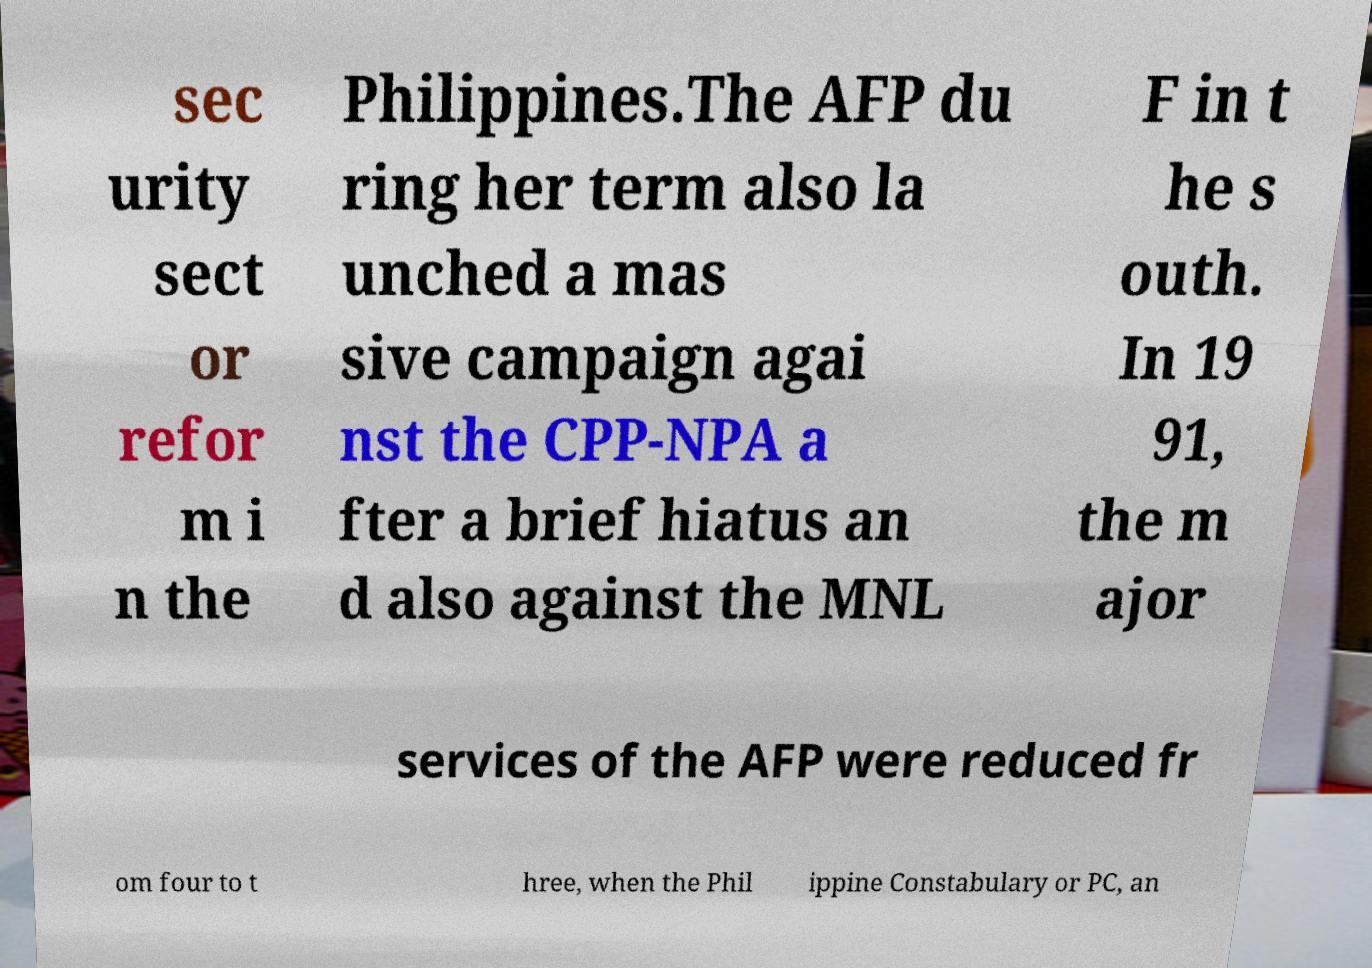Could you extract and type out the text from this image? sec urity sect or refor m i n the Philippines.The AFP du ring her term also la unched a mas sive campaign agai nst the CPP-NPA a fter a brief hiatus an d also against the MNL F in t he s outh. In 19 91, the m ajor services of the AFP were reduced fr om four to t hree, when the Phil ippine Constabulary or PC, an 